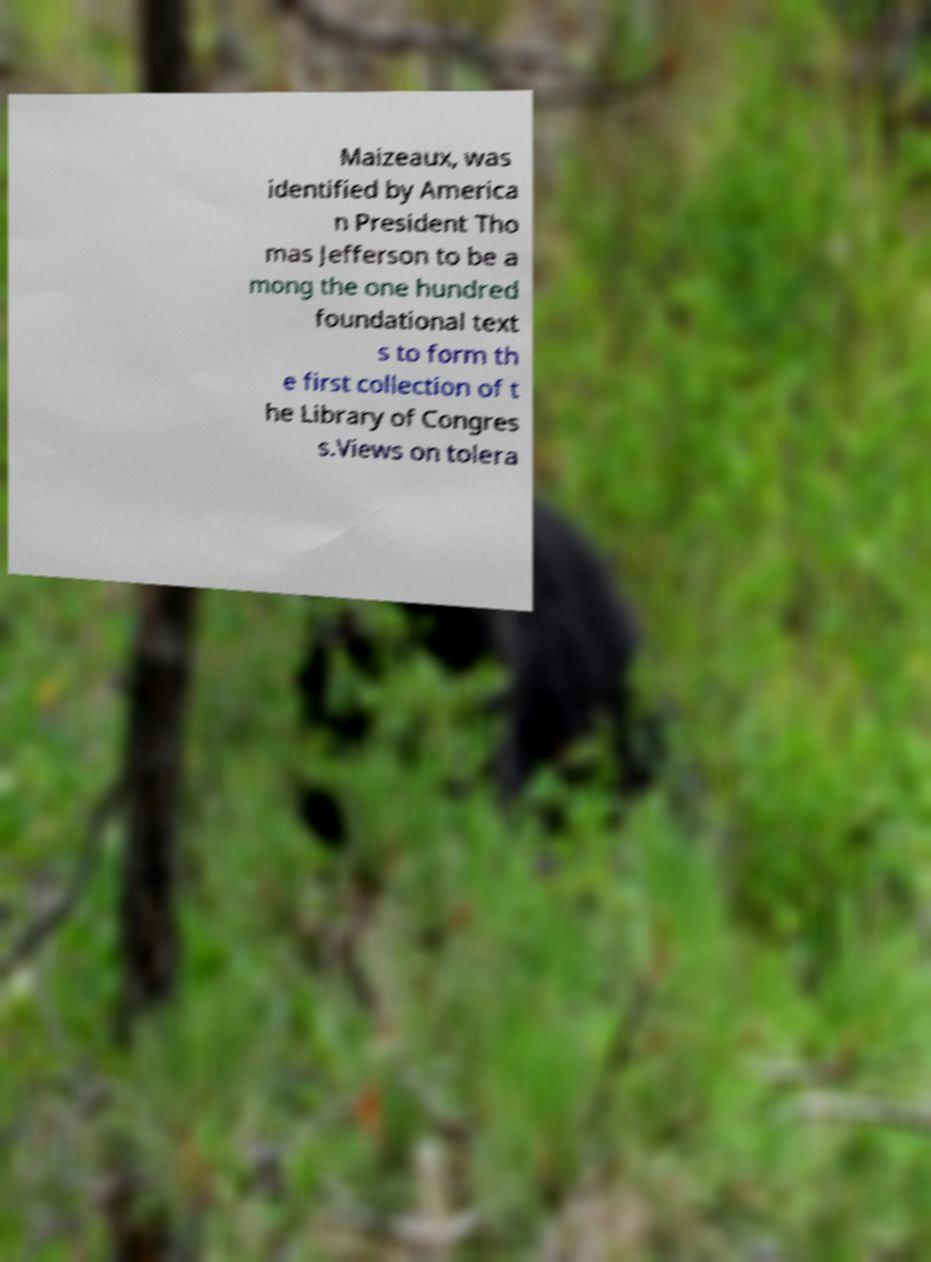Could you extract and type out the text from this image? Maizeaux, was identified by America n President Tho mas Jefferson to be a mong the one hundred foundational text s to form th e first collection of t he Library of Congres s.Views on tolera 